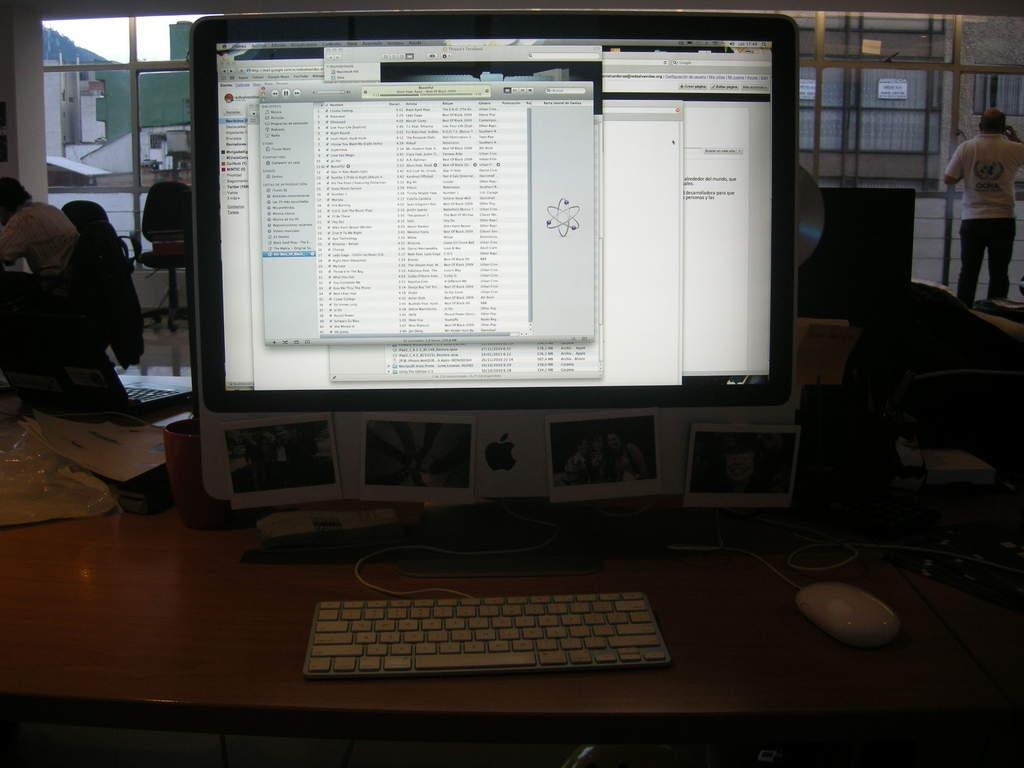<image>
Write a terse but informative summary of the picture. a lit up Apple computer monitor with a man in a OCHA shirt in the distance 